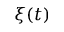Convert formula to latex. <formula><loc_0><loc_0><loc_500><loc_500>\xi ( t )</formula> 